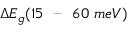Convert formula to latex. <formula><loc_0><loc_0><loc_500><loc_500>\Delta E _ { g } ( 1 5 \ - - \ 6 0 \ m e V )</formula> 